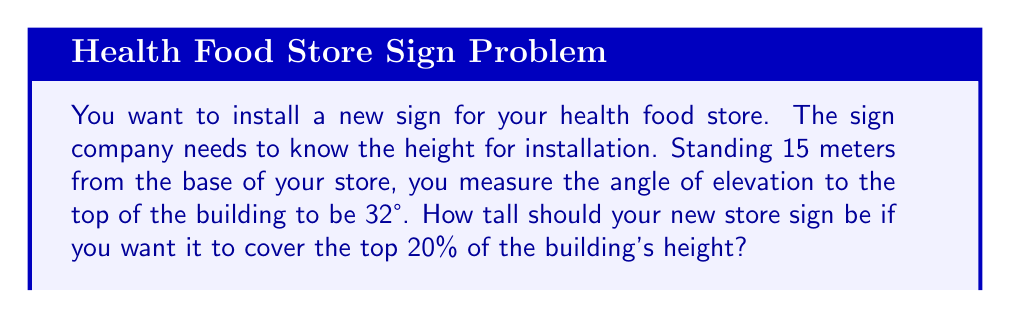Provide a solution to this math problem. Let's approach this step-by-step:

1) First, we need to find the total height of the building. We can use the tangent function for this.

2) In a right triangle formed by the building, your line of sight, and the ground:
   - The adjacent side is 15 meters (your distance from the building)
   - The angle of elevation is 32°
   - We need to find the opposite side (building height)

3) Using the tangent ratio:

   $$\tan(32°) = \frac{\text{opposite}}{\text{adjacent}} = \frac{\text{building height}}{15}$$

4) Solving for the building height:

   $$\text{building height} = 15 \times \tan(32°)$$

5) Calculate:
   $$\text{building height} = 15 \times 0.6249 = 9.3735 \text{ meters}$$

6) The sign should cover the top 20% of this height. To find 20% of 9.3735:

   $$9.3735 \times 0.20 = 1.8747 \text{ meters}$$

7) Round to two decimal places for practical measurement.

[asy]
import geometry;

pair A=(0,0), B=(0,9.3735), C=(15,0);
draw(A--B--C--A);
draw(C--B,dashed);
label("15 m",C--A,S);
label("9.3735 m",A--B,W);
label("32°",C,NE);
label("1.8747 m",B-(0,1.8747)--B,E);
[/asy]
Answer: 1.87 meters 